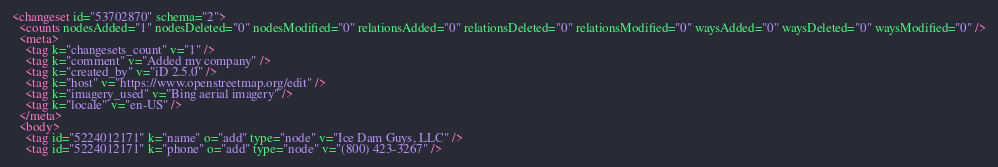Convert code to text. <code><loc_0><loc_0><loc_500><loc_500><_XML_><changeset id="53702870" schema="2">
  <counts nodesAdded="1" nodesDeleted="0" nodesModified="0" relationsAdded="0" relationsDeleted="0" relationsModified="0" waysAdded="0" waysDeleted="0" waysModified="0" />
  <meta>
    <tag k="changesets_count" v="1" />
    <tag k="comment" v="Added my company" />
    <tag k="created_by" v="iD 2.5.0" />
    <tag k="host" v="https://www.openstreetmap.org/edit" />
    <tag k="imagery_used" v="Bing aerial imagery" />
    <tag k="locale" v="en-US" />
  </meta>
  <body>
    <tag id="5224012171" k="name" o="add" type="node" v="Ice Dam Guys, LLC" />
    <tag id="5224012171" k="phone" o="add" type="node" v="(800) 423-3267" /></code> 